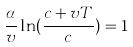<formula> <loc_0><loc_0><loc_500><loc_500>\frac { \alpha } { v } \ln ( \frac { c + v T } { c } ) = 1</formula> 